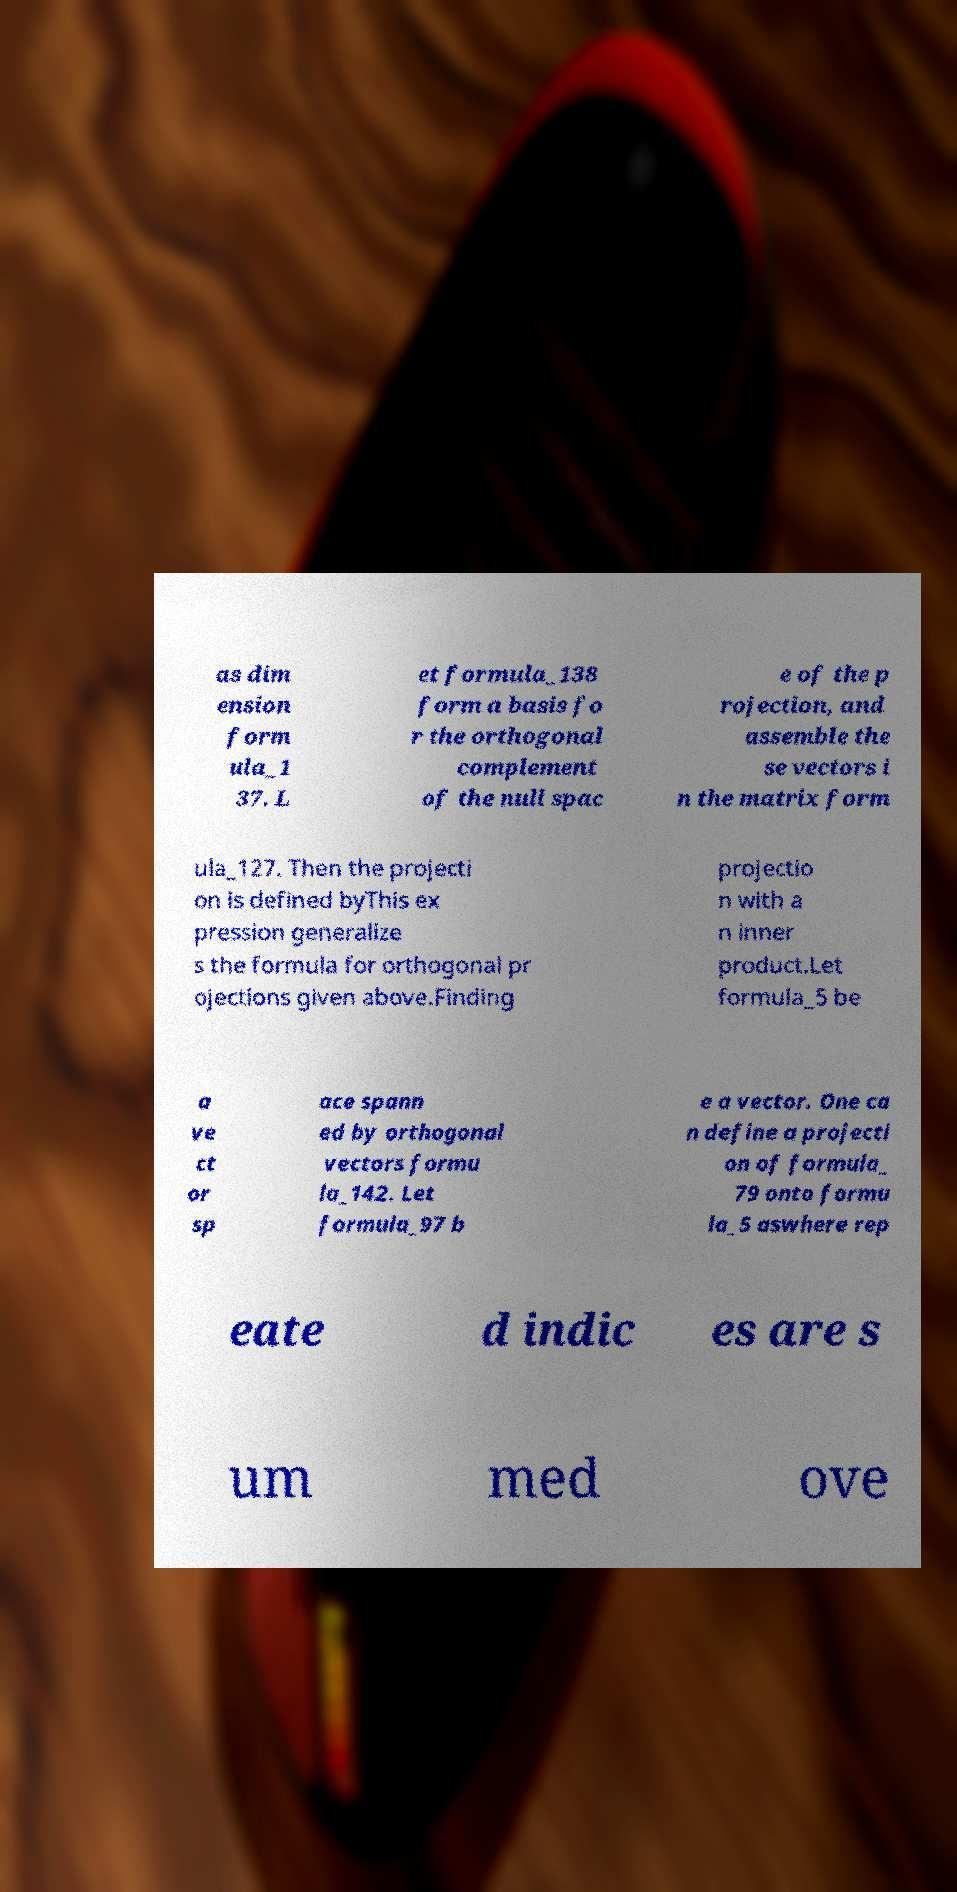Can you accurately transcribe the text from the provided image for me? as dim ension form ula_1 37. L et formula_138 form a basis fo r the orthogonal complement of the null spac e of the p rojection, and assemble the se vectors i n the matrix form ula_127. Then the projecti on is defined byThis ex pression generalize s the formula for orthogonal pr ojections given above.Finding projectio n with a n inner product.Let formula_5 be a ve ct or sp ace spann ed by orthogonal vectors formu la_142. Let formula_97 b e a vector. One ca n define a projecti on of formula_ 79 onto formu la_5 aswhere rep eate d indic es are s um med ove 